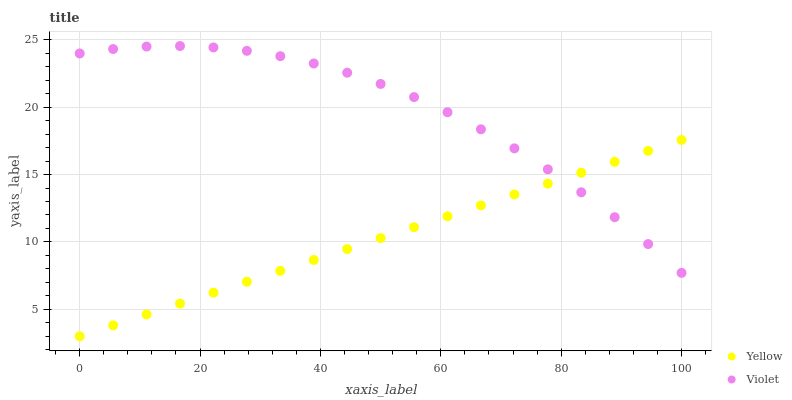Does Yellow have the minimum area under the curve?
Answer yes or no. Yes. Does Violet have the maximum area under the curve?
Answer yes or no. Yes. Does Violet have the minimum area under the curve?
Answer yes or no. No. Is Yellow the smoothest?
Answer yes or no. Yes. Is Violet the roughest?
Answer yes or no. Yes. Is Violet the smoothest?
Answer yes or no. No. Does Yellow have the lowest value?
Answer yes or no. Yes. Does Violet have the lowest value?
Answer yes or no. No. Does Violet have the highest value?
Answer yes or no. Yes. Does Violet intersect Yellow?
Answer yes or no. Yes. Is Violet less than Yellow?
Answer yes or no. No. Is Violet greater than Yellow?
Answer yes or no. No. 